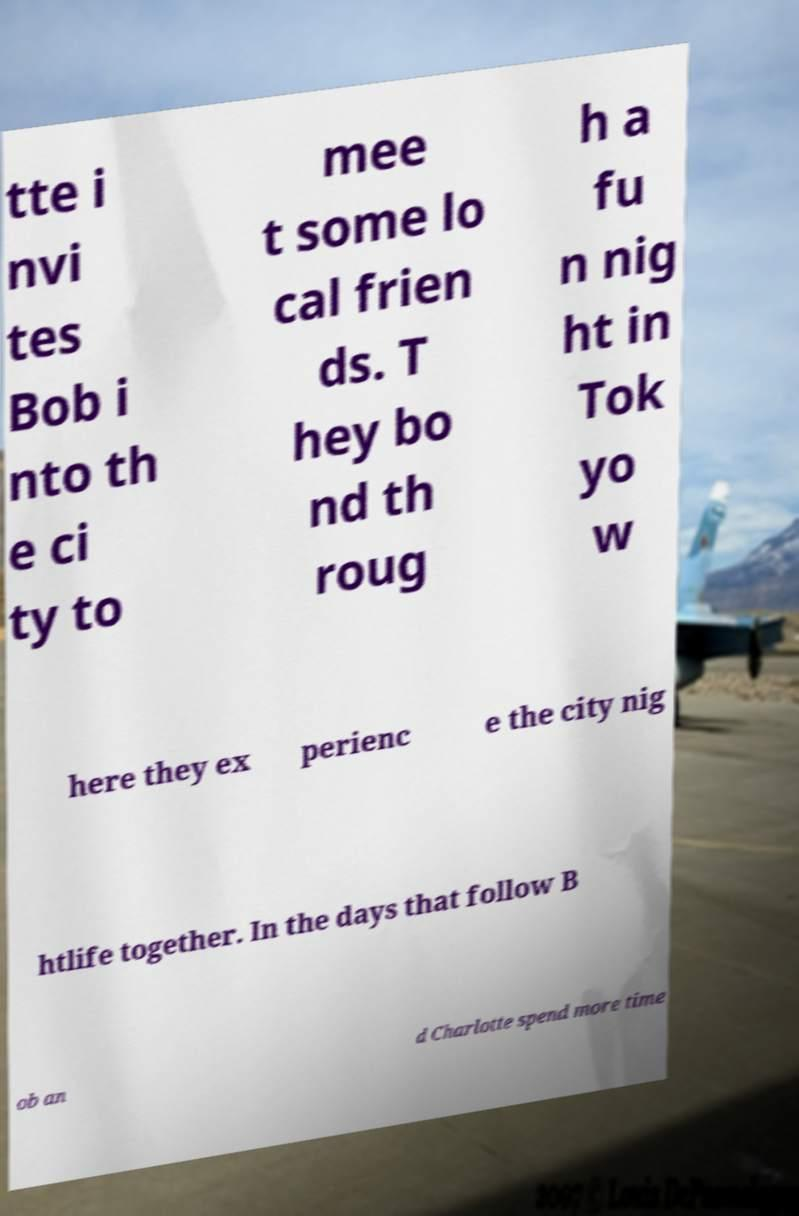Could you extract and type out the text from this image? tte i nvi tes Bob i nto th e ci ty to mee t some lo cal frien ds. T hey bo nd th roug h a fu n nig ht in Tok yo w here they ex perienc e the city nig htlife together. In the days that follow B ob an d Charlotte spend more time 